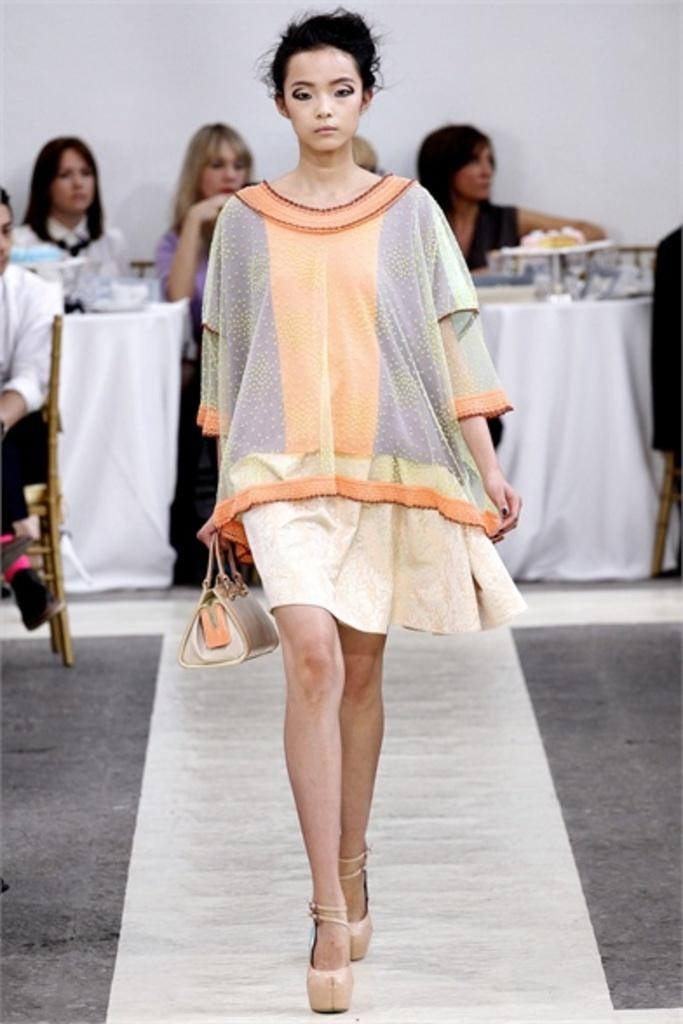What is the main subject of the image? There is a lady walking in the center of the image. What can be seen in the background of the image? There are people sitting in the background, as well as tables and a wall. What is placed on the tables in the image? There are objects placed on the tables. Can you see the tail of the animal in the image? There is no animal with a tail present in the image. What type of print is visible on the lady's shirt in the image? The facts provided do not mention any specific print on the lady's shirt, so we cannot determine that information from the image. 